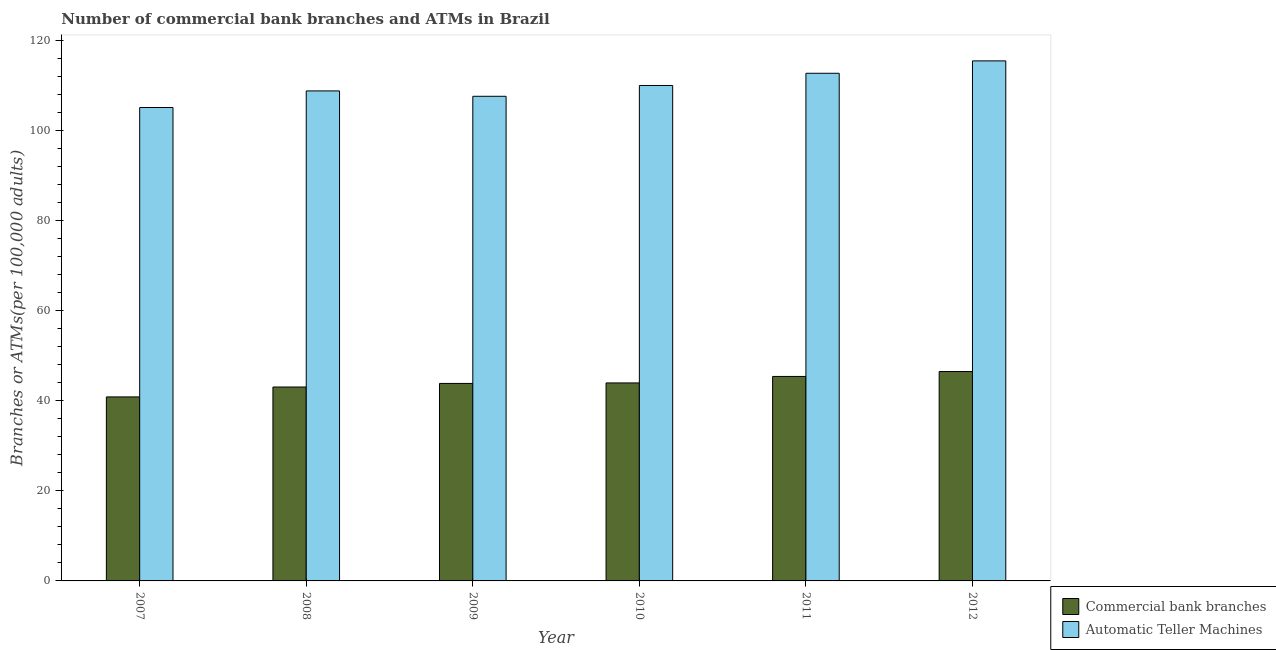How many different coloured bars are there?
Offer a terse response. 2. How many groups of bars are there?
Your answer should be very brief. 6. What is the label of the 2nd group of bars from the left?
Your response must be concise. 2008. What is the number of atms in 2008?
Provide a short and direct response. 108.88. Across all years, what is the maximum number of atms?
Ensure brevity in your answer.  115.55. Across all years, what is the minimum number of commercal bank branches?
Offer a very short reply. 40.88. What is the total number of atms in the graph?
Provide a short and direct response. 660.19. What is the difference between the number of atms in 2008 and that in 2009?
Make the answer very short. 1.2. What is the difference between the number of atms in 2012 and the number of commercal bank branches in 2010?
Your answer should be very brief. 5.47. What is the average number of atms per year?
Give a very brief answer. 110.03. In the year 2010, what is the difference between the number of commercal bank branches and number of atms?
Ensure brevity in your answer.  0. In how many years, is the number of commercal bank branches greater than 4?
Your answer should be compact. 6. What is the ratio of the number of atms in 2010 to that in 2011?
Offer a very short reply. 0.98. What is the difference between the highest and the second highest number of atms?
Ensure brevity in your answer.  2.75. What is the difference between the highest and the lowest number of atms?
Give a very brief answer. 10.36. In how many years, is the number of atms greater than the average number of atms taken over all years?
Your answer should be compact. 3. What does the 2nd bar from the left in 2011 represents?
Provide a short and direct response. Automatic Teller Machines. What does the 1st bar from the right in 2010 represents?
Your response must be concise. Automatic Teller Machines. How many bars are there?
Provide a short and direct response. 12. Are all the bars in the graph horizontal?
Provide a succinct answer. No. Are the values on the major ticks of Y-axis written in scientific E-notation?
Offer a terse response. No. Does the graph contain any zero values?
Offer a terse response. No. Does the graph contain grids?
Your answer should be compact. No. How are the legend labels stacked?
Ensure brevity in your answer.  Vertical. What is the title of the graph?
Make the answer very short. Number of commercial bank branches and ATMs in Brazil. What is the label or title of the Y-axis?
Offer a very short reply. Branches or ATMs(per 100,0 adults). What is the Branches or ATMs(per 100,000 adults) in Commercial bank branches in 2007?
Your answer should be compact. 40.88. What is the Branches or ATMs(per 100,000 adults) of Automatic Teller Machines in 2007?
Keep it short and to the point. 105.19. What is the Branches or ATMs(per 100,000 adults) in Commercial bank branches in 2008?
Give a very brief answer. 43.09. What is the Branches or ATMs(per 100,000 adults) in Automatic Teller Machines in 2008?
Provide a succinct answer. 108.88. What is the Branches or ATMs(per 100,000 adults) in Commercial bank branches in 2009?
Make the answer very short. 43.88. What is the Branches or ATMs(per 100,000 adults) of Automatic Teller Machines in 2009?
Offer a terse response. 107.68. What is the Branches or ATMs(per 100,000 adults) in Commercial bank branches in 2010?
Your response must be concise. 43.99. What is the Branches or ATMs(per 100,000 adults) of Automatic Teller Machines in 2010?
Your answer should be very brief. 110.09. What is the Branches or ATMs(per 100,000 adults) of Commercial bank branches in 2011?
Make the answer very short. 45.43. What is the Branches or ATMs(per 100,000 adults) in Automatic Teller Machines in 2011?
Offer a terse response. 112.8. What is the Branches or ATMs(per 100,000 adults) in Commercial bank branches in 2012?
Make the answer very short. 46.52. What is the Branches or ATMs(per 100,000 adults) of Automatic Teller Machines in 2012?
Your answer should be compact. 115.55. Across all years, what is the maximum Branches or ATMs(per 100,000 adults) of Commercial bank branches?
Provide a short and direct response. 46.52. Across all years, what is the maximum Branches or ATMs(per 100,000 adults) of Automatic Teller Machines?
Your answer should be very brief. 115.55. Across all years, what is the minimum Branches or ATMs(per 100,000 adults) in Commercial bank branches?
Give a very brief answer. 40.88. Across all years, what is the minimum Branches or ATMs(per 100,000 adults) of Automatic Teller Machines?
Provide a succinct answer. 105.19. What is the total Branches or ATMs(per 100,000 adults) in Commercial bank branches in the graph?
Give a very brief answer. 263.8. What is the total Branches or ATMs(per 100,000 adults) of Automatic Teller Machines in the graph?
Provide a succinct answer. 660.19. What is the difference between the Branches or ATMs(per 100,000 adults) in Commercial bank branches in 2007 and that in 2008?
Provide a succinct answer. -2.2. What is the difference between the Branches or ATMs(per 100,000 adults) in Automatic Teller Machines in 2007 and that in 2008?
Make the answer very short. -3.69. What is the difference between the Branches or ATMs(per 100,000 adults) of Commercial bank branches in 2007 and that in 2009?
Offer a terse response. -3. What is the difference between the Branches or ATMs(per 100,000 adults) in Automatic Teller Machines in 2007 and that in 2009?
Provide a succinct answer. -2.49. What is the difference between the Branches or ATMs(per 100,000 adults) of Commercial bank branches in 2007 and that in 2010?
Ensure brevity in your answer.  -3.11. What is the difference between the Branches or ATMs(per 100,000 adults) of Automatic Teller Machines in 2007 and that in 2010?
Provide a short and direct response. -4.9. What is the difference between the Branches or ATMs(per 100,000 adults) of Commercial bank branches in 2007 and that in 2011?
Ensure brevity in your answer.  -4.55. What is the difference between the Branches or ATMs(per 100,000 adults) of Automatic Teller Machines in 2007 and that in 2011?
Make the answer very short. -7.61. What is the difference between the Branches or ATMs(per 100,000 adults) of Commercial bank branches in 2007 and that in 2012?
Provide a short and direct response. -5.64. What is the difference between the Branches or ATMs(per 100,000 adults) of Automatic Teller Machines in 2007 and that in 2012?
Offer a terse response. -10.36. What is the difference between the Branches or ATMs(per 100,000 adults) in Commercial bank branches in 2008 and that in 2009?
Provide a succinct answer. -0.79. What is the difference between the Branches or ATMs(per 100,000 adults) in Automatic Teller Machines in 2008 and that in 2009?
Your answer should be compact. 1.2. What is the difference between the Branches or ATMs(per 100,000 adults) of Commercial bank branches in 2008 and that in 2010?
Provide a succinct answer. -0.91. What is the difference between the Branches or ATMs(per 100,000 adults) of Automatic Teller Machines in 2008 and that in 2010?
Keep it short and to the point. -1.21. What is the difference between the Branches or ATMs(per 100,000 adults) in Commercial bank branches in 2008 and that in 2011?
Give a very brief answer. -2.35. What is the difference between the Branches or ATMs(per 100,000 adults) of Automatic Teller Machines in 2008 and that in 2011?
Your answer should be compact. -3.92. What is the difference between the Branches or ATMs(per 100,000 adults) in Commercial bank branches in 2008 and that in 2012?
Offer a terse response. -3.44. What is the difference between the Branches or ATMs(per 100,000 adults) in Automatic Teller Machines in 2008 and that in 2012?
Keep it short and to the point. -6.67. What is the difference between the Branches or ATMs(per 100,000 adults) in Commercial bank branches in 2009 and that in 2010?
Your answer should be compact. -0.11. What is the difference between the Branches or ATMs(per 100,000 adults) in Automatic Teller Machines in 2009 and that in 2010?
Your response must be concise. -2.4. What is the difference between the Branches or ATMs(per 100,000 adults) in Commercial bank branches in 2009 and that in 2011?
Your response must be concise. -1.55. What is the difference between the Branches or ATMs(per 100,000 adults) in Automatic Teller Machines in 2009 and that in 2011?
Make the answer very short. -5.12. What is the difference between the Branches or ATMs(per 100,000 adults) in Commercial bank branches in 2009 and that in 2012?
Provide a succinct answer. -2.64. What is the difference between the Branches or ATMs(per 100,000 adults) in Automatic Teller Machines in 2009 and that in 2012?
Provide a short and direct response. -7.87. What is the difference between the Branches or ATMs(per 100,000 adults) in Commercial bank branches in 2010 and that in 2011?
Provide a short and direct response. -1.44. What is the difference between the Branches or ATMs(per 100,000 adults) of Automatic Teller Machines in 2010 and that in 2011?
Keep it short and to the point. -2.71. What is the difference between the Branches or ATMs(per 100,000 adults) in Commercial bank branches in 2010 and that in 2012?
Keep it short and to the point. -2.53. What is the difference between the Branches or ATMs(per 100,000 adults) of Automatic Teller Machines in 2010 and that in 2012?
Provide a succinct answer. -5.47. What is the difference between the Branches or ATMs(per 100,000 adults) in Commercial bank branches in 2011 and that in 2012?
Offer a very short reply. -1.09. What is the difference between the Branches or ATMs(per 100,000 adults) in Automatic Teller Machines in 2011 and that in 2012?
Offer a terse response. -2.75. What is the difference between the Branches or ATMs(per 100,000 adults) in Commercial bank branches in 2007 and the Branches or ATMs(per 100,000 adults) in Automatic Teller Machines in 2008?
Make the answer very short. -67.99. What is the difference between the Branches or ATMs(per 100,000 adults) in Commercial bank branches in 2007 and the Branches or ATMs(per 100,000 adults) in Automatic Teller Machines in 2009?
Your response must be concise. -66.8. What is the difference between the Branches or ATMs(per 100,000 adults) of Commercial bank branches in 2007 and the Branches or ATMs(per 100,000 adults) of Automatic Teller Machines in 2010?
Provide a succinct answer. -69.2. What is the difference between the Branches or ATMs(per 100,000 adults) in Commercial bank branches in 2007 and the Branches or ATMs(per 100,000 adults) in Automatic Teller Machines in 2011?
Provide a succinct answer. -71.91. What is the difference between the Branches or ATMs(per 100,000 adults) in Commercial bank branches in 2007 and the Branches or ATMs(per 100,000 adults) in Automatic Teller Machines in 2012?
Keep it short and to the point. -74.67. What is the difference between the Branches or ATMs(per 100,000 adults) of Commercial bank branches in 2008 and the Branches or ATMs(per 100,000 adults) of Automatic Teller Machines in 2009?
Make the answer very short. -64.59. What is the difference between the Branches or ATMs(per 100,000 adults) in Commercial bank branches in 2008 and the Branches or ATMs(per 100,000 adults) in Automatic Teller Machines in 2010?
Offer a very short reply. -67. What is the difference between the Branches or ATMs(per 100,000 adults) in Commercial bank branches in 2008 and the Branches or ATMs(per 100,000 adults) in Automatic Teller Machines in 2011?
Your answer should be compact. -69.71. What is the difference between the Branches or ATMs(per 100,000 adults) in Commercial bank branches in 2008 and the Branches or ATMs(per 100,000 adults) in Automatic Teller Machines in 2012?
Provide a succinct answer. -72.46. What is the difference between the Branches or ATMs(per 100,000 adults) in Commercial bank branches in 2009 and the Branches or ATMs(per 100,000 adults) in Automatic Teller Machines in 2010?
Your answer should be very brief. -66.2. What is the difference between the Branches or ATMs(per 100,000 adults) in Commercial bank branches in 2009 and the Branches or ATMs(per 100,000 adults) in Automatic Teller Machines in 2011?
Your answer should be compact. -68.92. What is the difference between the Branches or ATMs(per 100,000 adults) of Commercial bank branches in 2009 and the Branches or ATMs(per 100,000 adults) of Automatic Teller Machines in 2012?
Ensure brevity in your answer.  -71.67. What is the difference between the Branches or ATMs(per 100,000 adults) in Commercial bank branches in 2010 and the Branches or ATMs(per 100,000 adults) in Automatic Teller Machines in 2011?
Give a very brief answer. -68.8. What is the difference between the Branches or ATMs(per 100,000 adults) of Commercial bank branches in 2010 and the Branches or ATMs(per 100,000 adults) of Automatic Teller Machines in 2012?
Provide a succinct answer. -71.56. What is the difference between the Branches or ATMs(per 100,000 adults) of Commercial bank branches in 2011 and the Branches or ATMs(per 100,000 adults) of Automatic Teller Machines in 2012?
Offer a terse response. -70.12. What is the average Branches or ATMs(per 100,000 adults) of Commercial bank branches per year?
Your response must be concise. 43.97. What is the average Branches or ATMs(per 100,000 adults) in Automatic Teller Machines per year?
Your answer should be very brief. 110.03. In the year 2007, what is the difference between the Branches or ATMs(per 100,000 adults) of Commercial bank branches and Branches or ATMs(per 100,000 adults) of Automatic Teller Machines?
Ensure brevity in your answer.  -64.31. In the year 2008, what is the difference between the Branches or ATMs(per 100,000 adults) in Commercial bank branches and Branches or ATMs(per 100,000 adults) in Automatic Teller Machines?
Give a very brief answer. -65.79. In the year 2009, what is the difference between the Branches or ATMs(per 100,000 adults) of Commercial bank branches and Branches or ATMs(per 100,000 adults) of Automatic Teller Machines?
Keep it short and to the point. -63.8. In the year 2010, what is the difference between the Branches or ATMs(per 100,000 adults) of Commercial bank branches and Branches or ATMs(per 100,000 adults) of Automatic Teller Machines?
Your answer should be very brief. -66.09. In the year 2011, what is the difference between the Branches or ATMs(per 100,000 adults) of Commercial bank branches and Branches or ATMs(per 100,000 adults) of Automatic Teller Machines?
Offer a very short reply. -67.37. In the year 2012, what is the difference between the Branches or ATMs(per 100,000 adults) in Commercial bank branches and Branches or ATMs(per 100,000 adults) in Automatic Teller Machines?
Ensure brevity in your answer.  -69.03. What is the ratio of the Branches or ATMs(per 100,000 adults) of Commercial bank branches in 2007 to that in 2008?
Ensure brevity in your answer.  0.95. What is the ratio of the Branches or ATMs(per 100,000 adults) of Automatic Teller Machines in 2007 to that in 2008?
Provide a short and direct response. 0.97. What is the ratio of the Branches or ATMs(per 100,000 adults) in Commercial bank branches in 2007 to that in 2009?
Offer a terse response. 0.93. What is the ratio of the Branches or ATMs(per 100,000 adults) in Automatic Teller Machines in 2007 to that in 2009?
Your answer should be compact. 0.98. What is the ratio of the Branches or ATMs(per 100,000 adults) of Commercial bank branches in 2007 to that in 2010?
Give a very brief answer. 0.93. What is the ratio of the Branches or ATMs(per 100,000 adults) in Automatic Teller Machines in 2007 to that in 2010?
Provide a short and direct response. 0.96. What is the ratio of the Branches or ATMs(per 100,000 adults) of Commercial bank branches in 2007 to that in 2011?
Your response must be concise. 0.9. What is the ratio of the Branches or ATMs(per 100,000 adults) of Automatic Teller Machines in 2007 to that in 2011?
Offer a terse response. 0.93. What is the ratio of the Branches or ATMs(per 100,000 adults) of Commercial bank branches in 2007 to that in 2012?
Make the answer very short. 0.88. What is the ratio of the Branches or ATMs(per 100,000 adults) of Automatic Teller Machines in 2007 to that in 2012?
Make the answer very short. 0.91. What is the ratio of the Branches or ATMs(per 100,000 adults) in Commercial bank branches in 2008 to that in 2009?
Your response must be concise. 0.98. What is the ratio of the Branches or ATMs(per 100,000 adults) of Automatic Teller Machines in 2008 to that in 2009?
Your answer should be very brief. 1.01. What is the ratio of the Branches or ATMs(per 100,000 adults) of Commercial bank branches in 2008 to that in 2010?
Provide a short and direct response. 0.98. What is the ratio of the Branches or ATMs(per 100,000 adults) of Commercial bank branches in 2008 to that in 2011?
Provide a succinct answer. 0.95. What is the ratio of the Branches or ATMs(per 100,000 adults) in Automatic Teller Machines in 2008 to that in 2011?
Provide a succinct answer. 0.97. What is the ratio of the Branches or ATMs(per 100,000 adults) of Commercial bank branches in 2008 to that in 2012?
Provide a short and direct response. 0.93. What is the ratio of the Branches or ATMs(per 100,000 adults) of Automatic Teller Machines in 2008 to that in 2012?
Your answer should be compact. 0.94. What is the ratio of the Branches or ATMs(per 100,000 adults) of Automatic Teller Machines in 2009 to that in 2010?
Make the answer very short. 0.98. What is the ratio of the Branches or ATMs(per 100,000 adults) in Commercial bank branches in 2009 to that in 2011?
Ensure brevity in your answer.  0.97. What is the ratio of the Branches or ATMs(per 100,000 adults) in Automatic Teller Machines in 2009 to that in 2011?
Give a very brief answer. 0.95. What is the ratio of the Branches or ATMs(per 100,000 adults) in Commercial bank branches in 2009 to that in 2012?
Your answer should be compact. 0.94. What is the ratio of the Branches or ATMs(per 100,000 adults) in Automatic Teller Machines in 2009 to that in 2012?
Keep it short and to the point. 0.93. What is the ratio of the Branches or ATMs(per 100,000 adults) in Commercial bank branches in 2010 to that in 2011?
Offer a terse response. 0.97. What is the ratio of the Branches or ATMs(per 100,000 adults) of Automatic Teller Machines in 2010 to that in 2011?
Ensure brevity in your answer.  0.98. What is the ratio of the Branches or ATMs(per 100,000 adults) in Commercial bank branches in 2010 to that in 2012?
Your response must be concise. 0.95. What is the ratio of the Branches or ATMs(per 100,000 adults) in Automatic Teller Machines in 2010 to that in 2012?
Your answer should be very brief. 0.95. What is the ratio of the Branches or ATMs(per 100,000 adults) in Commercial bank branches in 2011 to that in 2012?
Offer a terse response. 0.98. What is the ratio of the Branches or ATMs(per 100,000 adults) in Automatic Teller Machines in 2011 to that in 2012?
Offer a terse response. 0.98. What is the difference between the highest and the second highest Branches or ATMs(per 100,000 adults) of Commercial bank branches?
Make the answer very short. 1.09. What is the difference between the highest and the second highest Branches or ATMs(per 100,000 adults) of Automatic Teller Machines?
Ensure brevity in your answer.  2.75. What is the difference between the highest and the lowest Branches or ATMs(per 100,000 adults) of Commercial bank branches?
Provide a short and direct response. 5.64. What is the difference between the highest and the lowest Branches or ATMs(per 100,000 adults) of Automatic Teller Machines?
Your response must be concise. 10.36. 